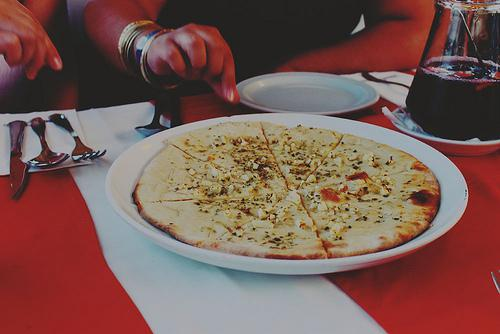Question: what is on the large plate?
Choices:
A. A pizza.
B. A donut.
C. A cookie.
D. A pie.
Answer with the letter. Answer: A Question: why is someone about to grab the pizza?
Choices:
A. To throw it away.
B. To eat it.
C. To take home.
D. To give away.
Answer with the letter. Answer: B Question: what utensils are on the table?
Choices:
A. Forks.
B. Spoons.
C. Knives.
D. A fork, knife and spoon.
Answer with the letter. Answer: D Question: who is reaching for the pizza?
Choices:
A. The girl.
B. The boy.
C. The man.
D. Two people.
Answer with the letter. Answer: D 